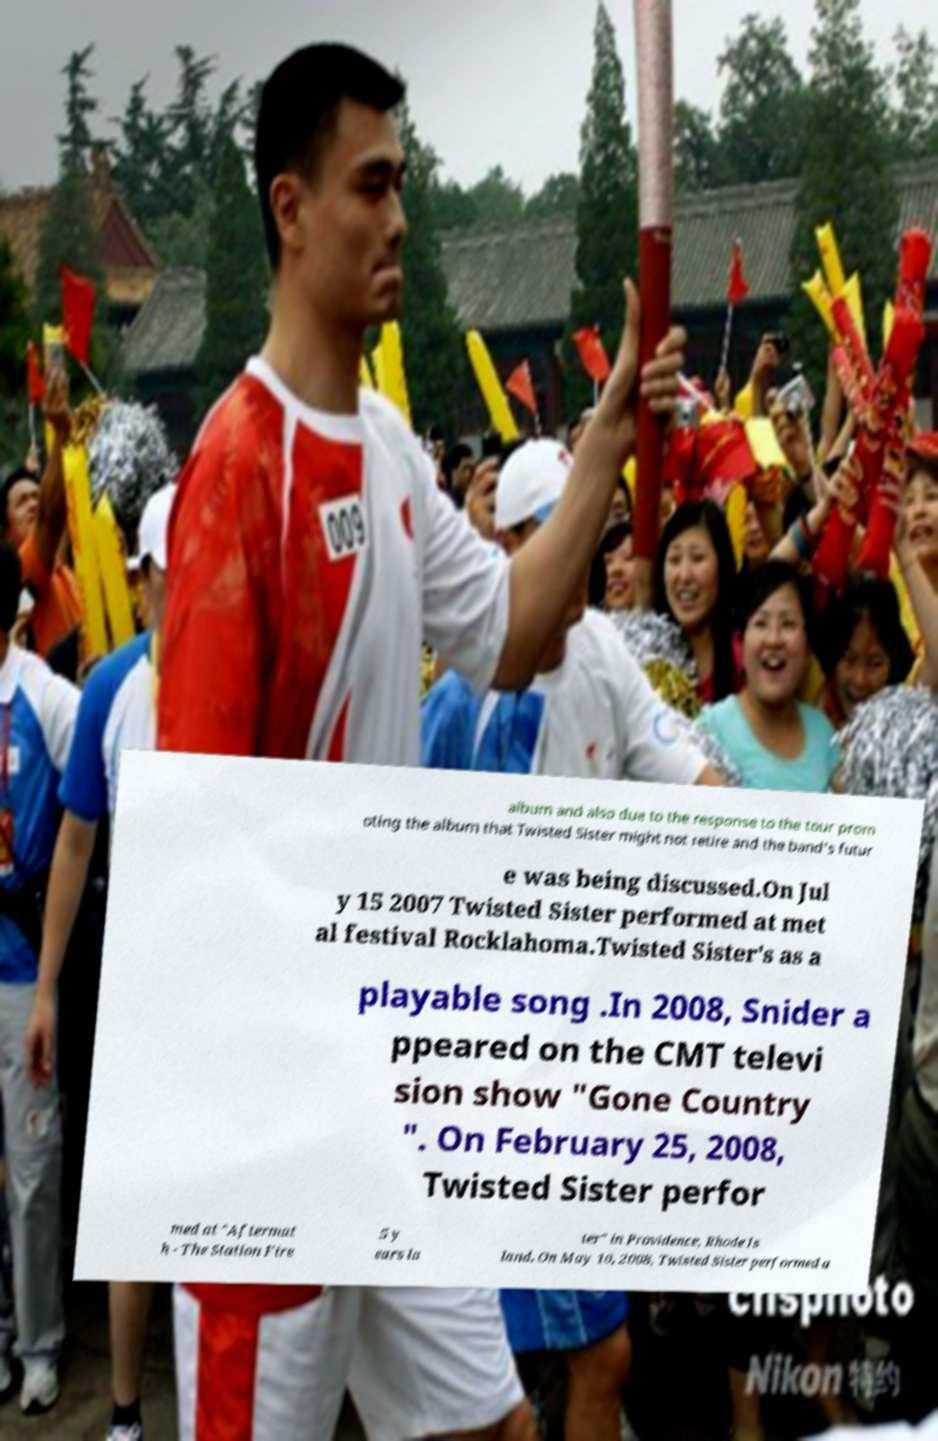Can you accurately transcribe the text from the provided image for me? album and also due to the response to the tour prom oting the album that Twisted Sister might not retire and the band's futur e was being discussed.On Jul y 15 2007 Twisted Sister performed at met al festival Rocklahoma.Twisted Sister's as a playable song .In 2008, Snider a ppeared on the CMT televi sion show "Gone Country ". On February 25, 2008, Twisted Sister perfor med at "Aftermat h - The Station Fire 5 y ears la ter" in Providence, Rhode Is land. On May 10, 2008, Twisted Sister performed a 